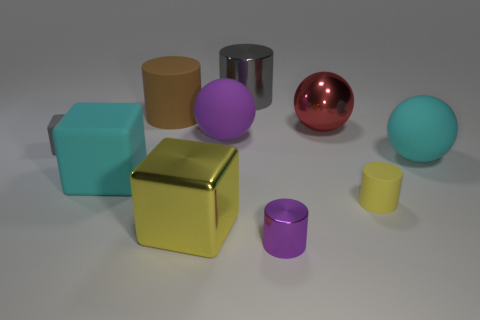Subtract all purple cylinders. How many cylinders are left? 3 Subtract 1 balls. How many balls are left? 2 Subtract all purple cylinders. How many cylinders are left? 3 Subtract all cylinders. How many objects are left? 6 Subtract all brown cylinders. Subtract all red balls. How many cylinders are left? 3 Subtract all brown cylinders. Subtract all small yellow rubber cylinders. How many objects are left? 8 Add 2 gray shiny things. How many gray shiny things are left? 3 Add 7 red things. How many red things exist? 8 Subtract 0 brown balls. How many objects are left? 10 